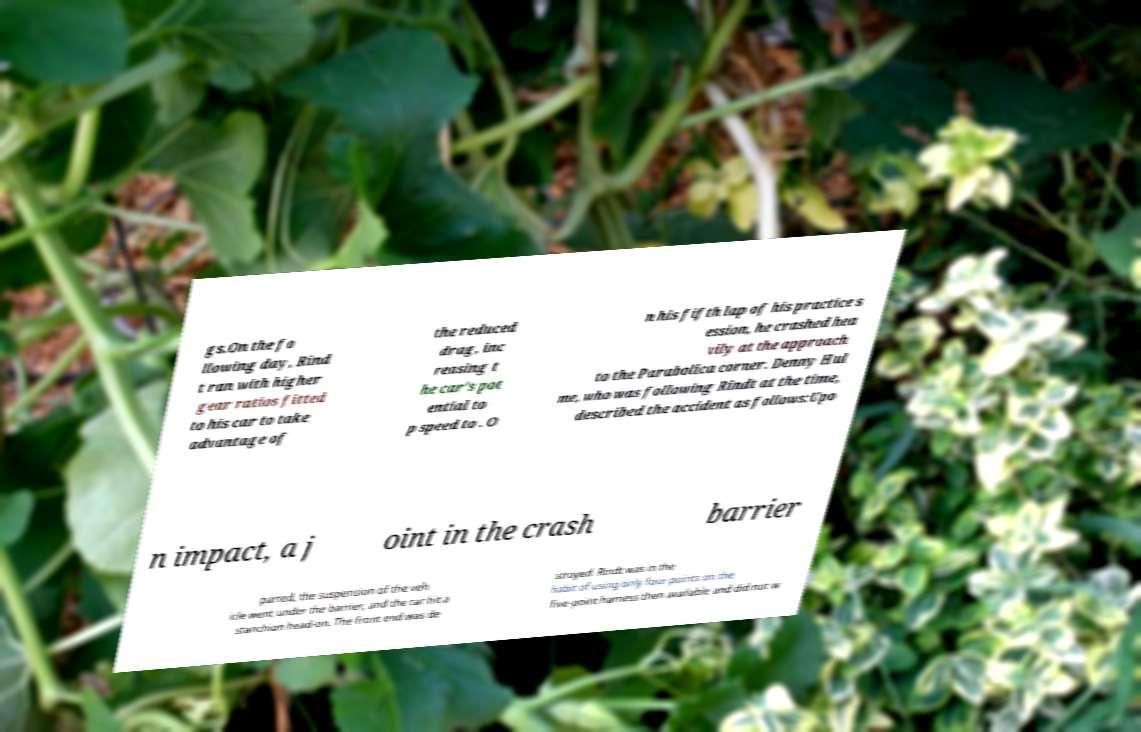Please read and relay the text visible in this image. What does it say? gs.On the fo llowing day, Rind t ran with higher gear ratios fitted to his car to take advantage of the reduced drag, inc reasing t he car's pot ential to p speed to . O n his fifth lap of his practice s ession, he crashed hea vily at the approach to the Parabolica corner. Denny Hul me, who was following Rindt at the time, described the accident as follows:Upo n impact, a j oint in the crash barrier parted, the suspension of the veh icle went under the barrier, and the car hit a stanchion head-on. The front end was de stroyed. Rindt was in the habit of using only four points on the five-point harness then available and did not w 